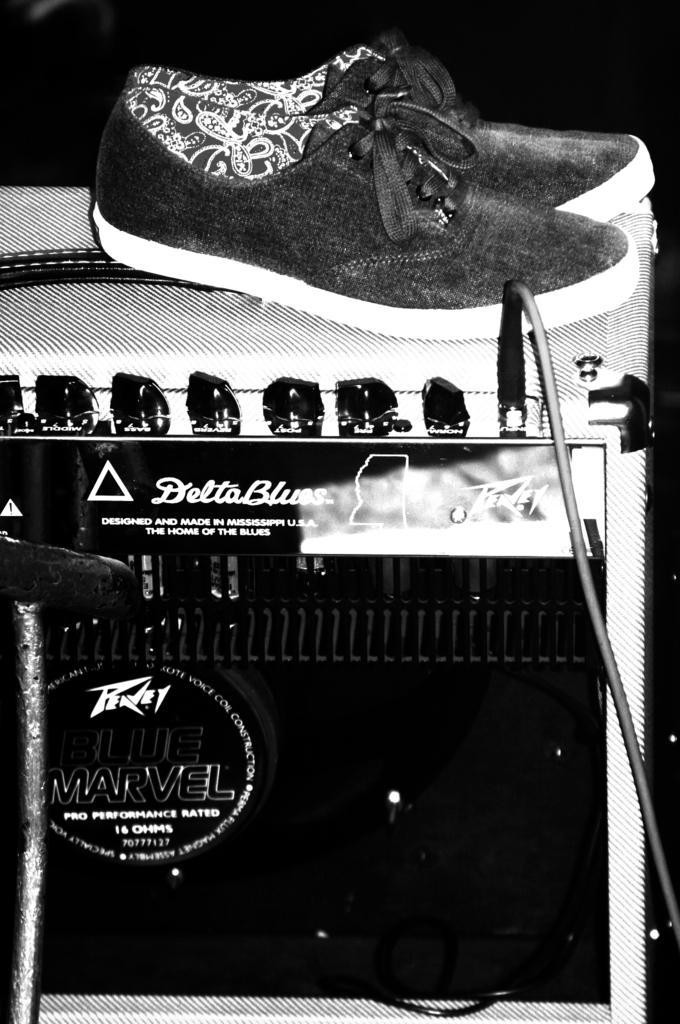Please provide a concise description of this image. In the front of the image there is a device, cable, pair of shoes and an object. In the background of the image it is dark. 